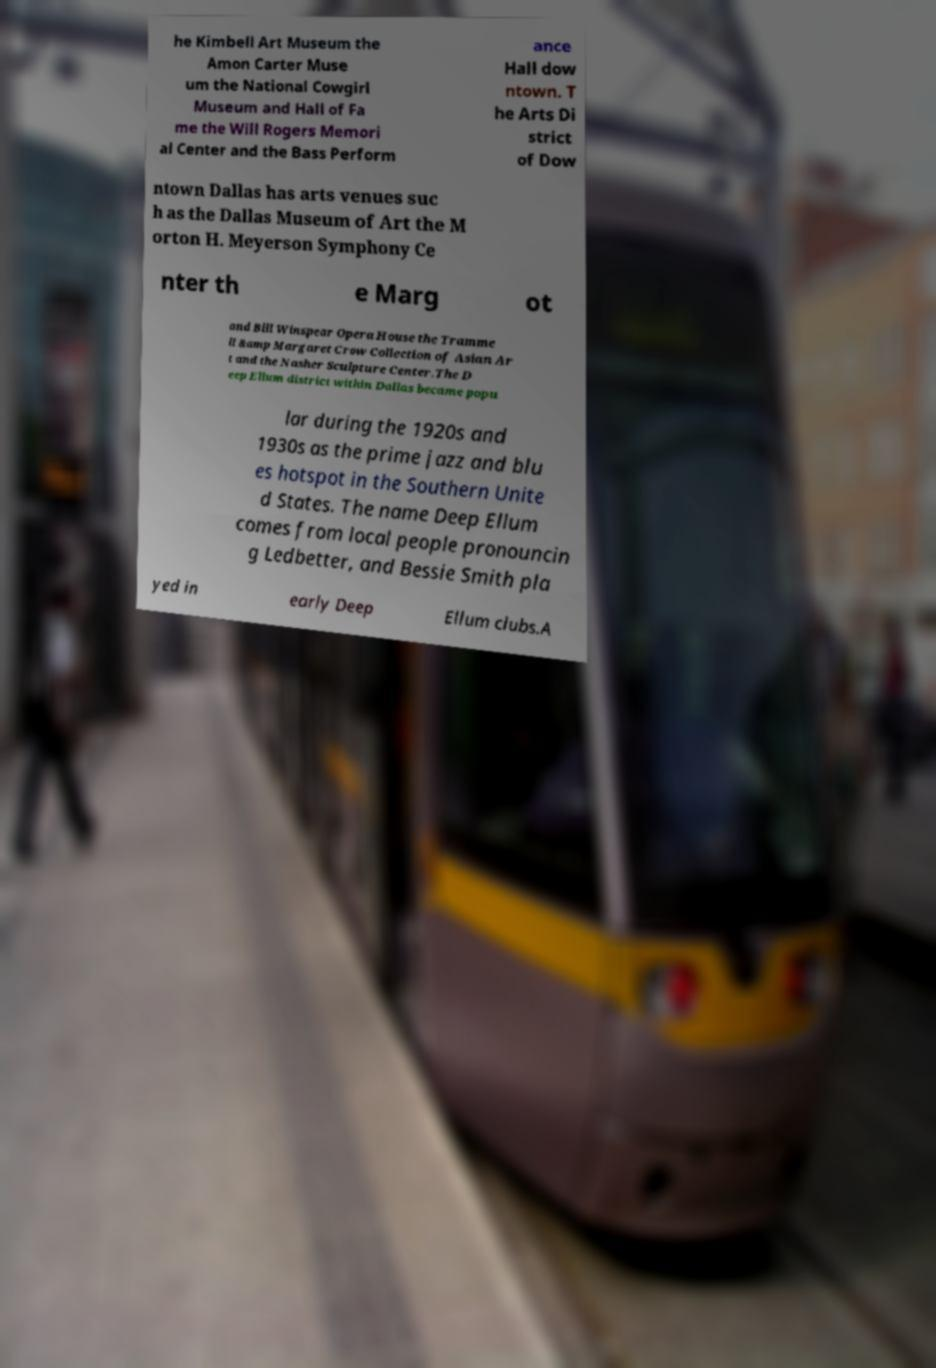There's text embedded in this image that I need extracted. Can you transcribe it verbatim? he Kimbell Art Museum the Amon Carter Muse um the National Cowgirl Museum and Hall of Fa me the Will Rogers Memori al Center and the Bass Perform ance Hall dow ntown. T he Arts Di strict of Dow ntown Dallas has arts venues suc h as the Dallas Museum of Art the M orton H. Meyerson Symphony Ce nter th e Marg ot and Bill Winspear Opera House the Tramme ll &amp Margaret Crow Collection of Asian Ar t and the Nasher Sculpture Center.The D eep Ellum district within Dallas became popu lar during the 1920s and 1930s as the prime jazz and blu es hotspot in the Southern Unite d States. The name Deep Ellum comes from local people pronouncin g Ledbetter, and Bessie Smith pla yed in early Deep Ellum clubs.A 